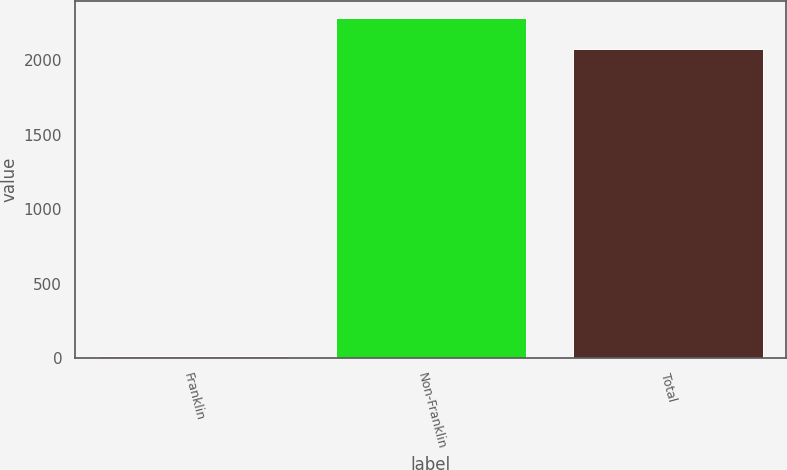Convert chart. <chart><loc_0><loc_0><loc_500><loc_500><bar_chart><fcel>Franklin<fcel>Non-Franklin<fcel>Total<nl><fcel>14.1<fcel>2282.17<fcel>2074.7<nl></chart> 